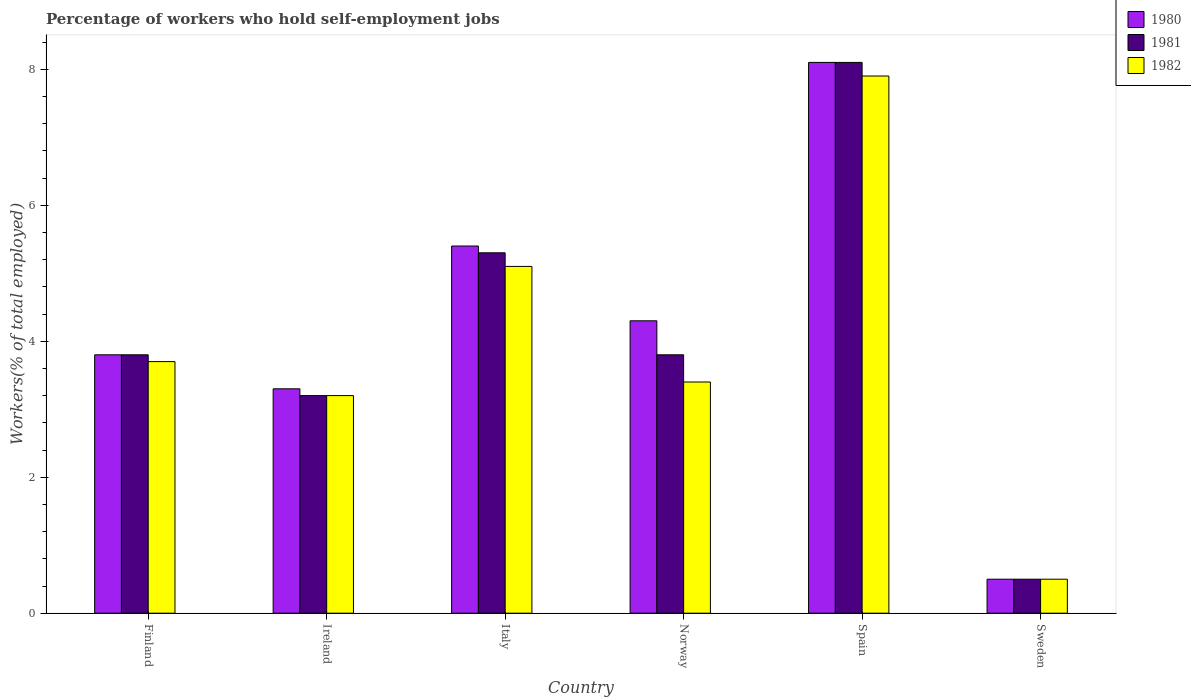Are the number of bars on each tick of the X-axis equal?
Your answer should be compact. Yes. How many bars are there on the 3rd tick from the left?
Your answer should be very brief. 3. How many bars are there on the 5th tick from the right?
Offer a terse response. 3. In how many cases, is the number of bars for a given country not equal to the number of legend labels?
Ensure brevity in your answer.  0. Across all countries, what is the maximum percentage of self-employed workers in 1980?
Make the answer very short. 8.1. Across all countries, what is the minimum percentage of self-employed workers in 1981?
Make the answer very short. 0.5. In which country was the percentage of self-employed workers in 1982 minimum?
Your answer should be very brief. Sweden. What is the total percentage of self-employed workers in 1980 in the graph?
Your response must be concise. 25.4. What is the difference between the percentage of self-employed workers in 1980 in Spain and that in Sweden?
Your answer should be compact. 7.6. What is the difference between the percentage of self-employed workers in 1982 in Sweden and the percentage of self-employed workers in 1981 in Italy?
Make the answer very short. -4.8. What is the average percentage of self-employed workers in 1981 per country?
Your answer should be compact. 4.12. What is the difference between the percentage of self-employed workers of/in 1982 and percentage of self-employed workers of/in 1980 in Norway?
Your answer should be compact. -0.9. In how many countries, is the percentage of self-employed workers in 1981 greater than 6.4 %?
Make the answer very short. 1. What is the ratio of the percentage of self-employed workers in 1982 in Spain to that in Sweden?
Offer a terse response. 15.8. Is the difference between the percentage of self-employed workers in 1982 in Ireland and Spain greater than the difference between the percentage of self-employed workers in 1980 in Ireland and Spain?
Ensure brevity in your answer.  Yes. What is the difference between the highest and the second highest percentage of self-employed workers in 1981?
Give a very brief answer. 4.3. What is the difference between the highest and the lowest percentage of self-employed workers in 1980?
Provide a succinct answer. 7.6. In how many countries, is the percentage of self-employed workers in 1982 greater than the average percentage of self-employed workers in 1982 taken over all countries?
Keep it short and to the point. 2. What does the 3rd bar from the right in Sweden represents?
Your response must be concise. 1980. Are all the bars in the graph horizontal?
Ensure brevity in your answer.  No. What is the difference between two consecutive major ticks on the Y-axis?
Ensure brevity in your answer.  2. Does the graph contain any zero values?
Your answer should be compact. No. Does the graph contain grids?
Your answer should be compact. No. Where does the legend appear in the graph?
Provide a succinct answer. Top right. How are the legend labels stacked?
Provide a succinct answer. Vertical. What is the title of the graph?
Keep it short and to the point. Percentage of workers who hold self-employment jobs. Does "1991" appear as one of the legend labels in the graph?
Your answer should be very brief. No. What is the label or title of the X-axis?
Offer a very short reply. Country. What is the label or title of the Y-axis?
Provide a short and direct response. Workers(% of total employed). What is the Workers(% of total employed) of 1980 in Finland?
Keep it short and to the point. 3.8. What is the Workers(% of total employed) in 1981 in Finland?
Your answer should be compact. 3.8. What is the Workers(% of total employed) in 1982 in Finland?
Provide a succinct answer. 3.7. What is the Workers(% of total employed) in 1980 in Ireland?
Provide a succinct answer. 3.3. What is the Workers(% of total employed) of 1981 in Ireland?
Provide a short and direct response. 3.2. What is the Workers(% of total employed) of 1982 in Ireland?
Keep it short and to the point. 3.2. What is the Workers(% of total employed) of 1980 in Italy?
Your response must be concise. 5.4. What is the Workers(% of total employed) in 1981 in Italy?
Provide a short and direct response. 5.3. What is the Workers(% of total employed) in 1982 in Italy?
Offer a terse response. 5.1. What is the Workers(% of total employed) in 1980 in Norway?
Give a very brief answer. 4.3. What is the Workers(% of total employed) of 1981 in Norway?
Ensure brevity in your answer.  3.8. What is the Workers(% of total employed) in 1982 in Norway?
Provide a succinct answer. 3.4. What is the Workers(% of total employed) in 1980 in Spain?
Your answer should be compact. 8.1. What is the Workers(% of total employed) of 1981 in Spain?
Give a very brief answer. 8.1. What is the Workers(% of total employed) in 1982 in Spain?
Your answer should be very brief. 7.9. What is the Workers(% of total employed) of 1980 in Sweden?
Offer a very short reply. 0.5. Across all countries, what is the maximum Workers(% of total employed) of 1980?
Provide a short and direct response. 8.1. Across all countries, what is the maximum Workers(% of total employed) in 1981?
Your answer should be compact. 8.1. Across all countries, what is the maximum Workers(% of total employed) in 1982?
Ensure brevity in your answer.  7.9. What is the total Workers(% of total employed) of 1980 in the graph?
Keep it short and to the point. 25.4. What is the total Workers(% of total employed) in 1981 in the graph?
Provide a succinct answer. 24.7. What is the total Workers(% of total employed) of 1982 in the graph?
Provide a succinct answer. 23.8. What is the difference between the Workers(% of total employed) of 1982 in Finland and that in Ireland?
Provide a succinct answer. 0.5. What is the difference between the Workers(% of total employed) in 1981 in Finland and that in Italy?
Provide a succinct answer. -1.5. What is the difference between the Workers(% of total employed) in 1982 in Finland and that in Italy?
Provide a short and direct response. -1.4. What is the difference between the Workers(% of total employed) of 1980 in Finland and that in Norway?
Offer a terse response. -0.5. What is the difference between the Workers(% of total employed) of 1982 in Finland and that in Norway?
Offer a terse response. 0.3. What is the difference between the Workers(% of total employed) of 1980 in Finland and that in Spain?
Offer a terse response. -4.3. What is the difference between the Workers(% of total employed) in 1981 in Finland and that in Spain?
Your answer should be compact. -4.3. What is the difference between the Workers(% of total employed) of 1982 in Finland and that in Spain?
Keep it short and to the point. -4.2. What is the difference between the Workers(% of total employed) in 1981 in Ireland and that in Italy?
Ensure brevity in your answer.  -2.1. What is the difference between the Workers(% of total employed) in 1982 in Ireland and that in Italy?
Your answer should be very brief. -1.9. What is the difference between the Workers(% of total employed) in 1980 in Ireland and that in Spain?
Your answer should be very brief. -4.8. What is the difference between the Workers(% of total employed) of 1981 in Ireland and that in Spain?
Your answer should be compact. -4.9. What is the difference between the Workers(% of total employed) of 1982 in Ireland and that in Spain?
Offer a terse response. -4.7. What is the difference between the Workers(% of total employed) of 1981 in Italy and that in Norway?
Offer a very short reply. 1.5. What is the difference between the Workers(% of total employed) of 1982 in Italy and that in Norway?
Ensure brevity in your answer.  1.7. What is the difference between the Workers(% of total employed) in 1982 in Italy and that in Spain?
Offer a very short reply. -2.8. What is the difference between the Workers(% of total employed) of 1980 in Italy and that in Sweden?
Provide a short and direct response. 4.9. What is the difference between the Workers(% of total employed) in 1980 in Norway and that in Spain?
Offer a terse response. -3.8. What is the difference between the Workers(% of total employed) in 1981 in Norway and that in Spain?
Provide a succinct answer. -4.3. What is the difference between the Workers(% of total employed) in 1982 in Norway and that in Spain?
Keep it short and to the point. -4.5. What is the difference between the Workers(% of total employed) of 1980 in Norway and that in Sweden?
Your answer should be compact. 3.8. What is the difference between the Workers(% of total employed) of 1981 in Norway and that in Sweden?
Provide a short and direct response. 3.3. What is the difference between the Workers(% of total employed) of 1981 in Spain and that in Sweden?
Your response must be concise. 7.6. What is the difference between the Workers(% of total employed) in 1980 in Finland and the Workers(% of total employed) in 1981 in Ireland?
Offer a terse response. 0.6. What is the difference between the Workers(% of total employed) of 1981 in Finland and the Workers(% of total employed) of 1982 in Ireland?
Make the answer very short. 0.6. What is the difference between the Workers(% of total employed) in 1981 in Finland and the Workers(% of total employed) in 1982 in Norway?
Ensure brevity in your answer.  0.4. What is the difference between the Workers(% of total employed) of 1980 in Finland and the Workers(% of total employed) of 1981 in Sweden?
Offer a terse response. 3.3. What is the difference between the Workers(% of total employed) in 1980 in Ireland and the Workers(% of total employed) in 1982 in Norway?
Offer a very short reply. -0.1. What is the difference between the Workers(% of total employed) of 1981 in Ireland and the Workers(% of total employed) of 1982 in Norway?
Ensure brevity in your answer.  -0.2. What is the difference between the Workers(% of total employed) in 1980 in Ireland and the Workers(% of total employed) in 1981 in Spain?
Offer a very short reply. -4.8. What is the difference between the Workers(% of total employed) of 1980 in Ireland and the Workers(% of total employed) of 1982 in Spain?
Offer a very short reply. -4.6. What is the difference between the Workers(% of total employed) in 1981 in Ireland and the Workers(% of total employed) in 1982 in Spain?
Offer a very short reply. -4.7. What is the difference between the Workers(% of total employed) of 1980 in Ireland and the Workers(% of total employed) of 1982 in Sweden?
Provide a short and direct response. 2.8. What is the difference between the Workers(% of total employed) of 1980 in Italy and the Workers(% of total employed) of 1981 in Spain?
Make the answer very short. -2.7. What is the difference between the Workers(% of total employed) of 1980 in Italy and the Workers(% of total employed) of 1982 in Spain?
Your answer should be very brief. -2.5. What is the difference between the Workers(% of total employed) of 1981 in Italy and the Workers(% of total employed) of 1982 in Spain?
Give a very brief answer. -2.6. What is the difference between the Workers(% of total employed) in 1980 in Italy and the Workers(% of total employed) in 1981 in Sweden?
Give a very brief answer. 4.9. What is the difference between the Workers(% of total employed) of 1981 in Italy and the Workers(% of total employed) of 1982 in Sweden?
Your response must be concise. 4.8. What is the difference between the Workers(% of total employed) of 1980 in Norway and the Workers(% of total employed) of 1981 in Spain?
Provide a succinct answer. -3.8. What is the difference between the Workers(% of total employed) of 1980 in Norway and the Workers(% of total employed) of 1981 in Sweden?
Give a very brief answer. 3.8. What is the difference between the Workers(% of total employed) in 1980 in Spain and the Workers(% of total employed) in 1981 in Sweden?
Give a very brief answer. 7.6. What is the difference between the Workers(% of total employed) in 1980 in Spain and the Workers(% of total employed) in 1982 in Sweden?
Keep it short and to the point. 7.6. What is the average Workers(% of total employed) in 1980 per country?
Your answer should be compact. 4.23. What is the average Workers(% of total employed) in 1981 per country?
Offer a very short reply. 4.12. What is the average Workers(% of total employed) of 1982 per country?
Provide a succinct answer. 3.97. What is the difference between the Workers(% of total employed) of 1980 and Workers(% of total employed) of 1981 in Finland?
Give a very brief answer. 0. What is the difference between the Workers(% of total employed) in 1980 and Workers(% of total employed) in 1982 in Finland?
Offer a terse response. 0.1. What is the difference between the Workers(% of total employed) in 1981 and Workers(% of total employed) in 1982 in Finland?
Keep it short and to the point. 0.1. What is the difference between the Workers(% of total employed) in 1980 and Workers(% of total employed) in 1981 in Ireland?
Offer a very short reply. 0.1. What is the difference between the Workers(% of total employed) in 1980 and Workers(% of total employed) in 1982 in Ireland?
Your answer should be compact. 0.1. What is the difference between the Workers(% of total employed) in 1981 and Workers(% of total employed) in 1982 in Italy?
Provide a short and direct response. 0.2. What is the difference between the Workers(% of total employed) of 1980 and Workers(% of total employed) of 1981 in Norway?
Ensure brevity in your answer.  0.5. What is the difference between the Workers(% of total employed) of 1980 and Workers(% of total employed) of 1982 in Norway?
Give a very brief answer. 0.9. What is the difference between the Workers(% of total employed) in 1981 and Workers(% of total employed) in 1982 in Norway?
Keep it short and to the point. 0.4. What is the difference between the Workers(% of total employed) in 1980 and Workers(% of total employed) in 1981 in Spain?
Your answer should be very brief. 0. What is the difference between the Workers(% of total employed) in 1980 and Workers(% of total employed) in 1981 in Sweden?
Provide a succinct answer. 0. What is the difference between the Workers(% of total employed) of 1981 and Workers(% of total employed) of 1982 in Sweden?
Your answer should be very brief. 0. What is the ratio of the Workers(% of total employed) in 1980 in Finland to that in Ireland?
Your answer should be very brief. 1.15. What is the ratio of the Workers(% of total employed) of 1981 in Finland to that in Ireland?
Provide a succinct answer. 1.19. What is the ratio of the Workers(% of total employed) of 1982 in Finland to that in Ireland?
Offer a very short reply. 1.16. What is the ratio of the Workers(% of total employed) of 1980 in Finland to that in Italy?
Offer a terse response. 0.7. What is the ratio of the Workers(% of total employed) of 1981 in Finland to that in Italy?
Your answer should be compact. 0.72. What is the ratio of the Workers(% of total employed) in 1982 in Finland to that in Italy?
Offer a terse response. 0.73. What is the ratio of the Workers(% of total employed) of 1980 in Finland to that in Norway?
Keep it short and to the point. 0.88. What is the ratio of the Workers(% of total employed) of 1981 in Finland to that in Norway?
Provide a succinct answer. 1. What is the ratio of the Workers(% of total employed) of 1982 in Finland to that in Norway?
Your answer should be compact. 1.09. What is the ratio of the Workers(% of total employed) of 1980 in Finland to that in Spain?
Offer a very short reply. 0.47. What is the ratio of the Workers(% of total employed) in 1981 in Finland to that in Spain?
Ensure brevity in your answer.  0.47. What is the ratio of the Workers(% of total employed) in 1982 in Finland to that in Spain?
Offer a very short reply. 0.47. What is the ratio of the Workers(% of total employed) of 1980 in Finland to that in Sweden?
Offer a terse response. 7.6. What is the ratio of the Workers(% of total employed) in 1980 in Ireland to that in Italy?
Offer a very short reply. 0.61. What is the ratio of the Workers(% of total employed) in 1981 in Ireland to that in Italy?
Make the answer very short. 0.6. What is the ratio of the Workers(% of total employed) of 1982 in Ireland to that in Italy?
Offer a terse response. 0.63. What is the ratio of the Workers(% of total employed) of 1980 in Ireland to that in Norway?
Provide a short and direct response. 0.77. What is the ratio of the Workers(% of total employed) in 1981 in Ireland to that in Norway?
Provide a succinct answer. 0.84. What is the ratio of the Workers(% of total employed) in 1980 in Ireland to that in Spain?
Make the answer very short. 0.41. What is the ratio of the Workers(% of total employed) of 1981 in Ireland to that in Spain?
Make the answer very short. 0.4. What is the ratio of the Workers(% of total employed) of 1982 in Ireland to that in Spain?
Offer a terse response. 0.41. What is the ratio of the Workers(% of total employed) of 1980 in Italy to that in Norway?
Your answer should be very brief. 1.26. What is the ratio of the Workers(% of total employed) in 1981 in Italy to that in Norway?
Ensure brevity in your answer.  1.39. What is the ratio of the Workers(% of total employed) of 1981 in Italy to that in Spain?
Offer a terse response. 0.65. What is the ratio of the Workers(% of total employed) of 1982 in Italy to that in Spain?
Offer a terse response. 0.65. What is the ratio of the Workers(% of total employed) in 1980 in Italy to that in Sweden?
Your answer should be compact. 10.8. What is the ratio of the Workers(% of total employed) of 1980 in Norway to that in Spain?
Offer a terse response. 0.53. What is the ratio of the Workers(% of total employed) of 1981 in Norway to that in Spain?
Provide a short and direct response. 0.47. What is the ratio of the Workers(% of total employed) of 1982 in Norway to that in Spain?
Your answer should be compact. 0.43. What is the ratio of the Workers(% of total employed) in 1981 in Norway to that in Sweden?
Your response must be concise. 7.6. What is the ratio of the Workers(% of total employed) in 1981 in Spain to that in Sweden?
Give a very brief answer. 16.2. What is the ratio of the Workers(% of total employed) in 1982 in Spain to that in Sweden?
Give a very brief answer. 15.8. What is the difference between the highest and the second highest Workers(% of total employed) in 1980?
Your answer should be compact. 2.7. What is the difference between the highest and the second highest Workers(% of total employed) in 1982?
Give a very brief answer. 2.8. What is the difference between the highest and the lowest Workers(% of total employed) of 1980?
Provide a short and direct response. 7.6. What is the difference between the highest and the lowest Workers(% of total employed) of 1982?
Ensure brevity in your answer.  7.4. 